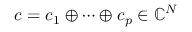Convert formula to latex. <formula><loc_0><loc_0><loc_500><loc_500>c = c _ { 1 } \oplus \cdots \oplus c _ { p } \in \mathbb { C } ^ { N }</formula> 